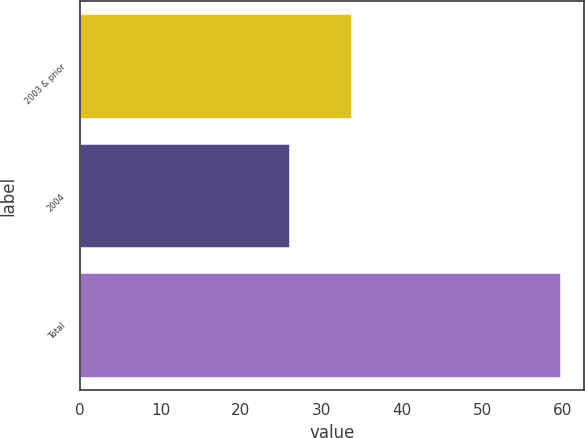Convert chart to OTSL. <chart><loc_0><loc_0><loc_500><loc_500><bar_chart><fcel>2003 & prior<fcel>2004<fcel>Total<nl><fcel>33.7<fcel>26<fcel>59.7<nl></chart> 